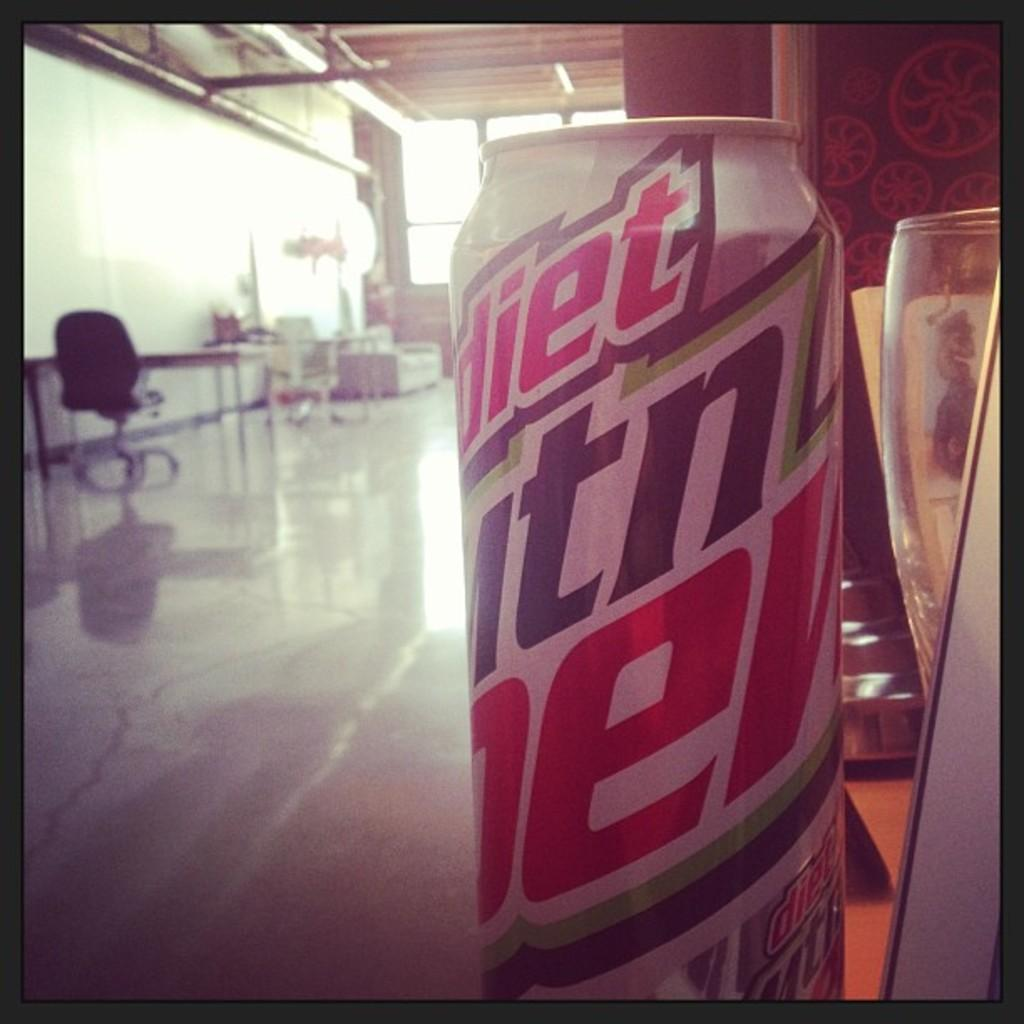<image>
Provide a brief description of the given image. A can of soda that says diet mtn dew is in an empty shop. 